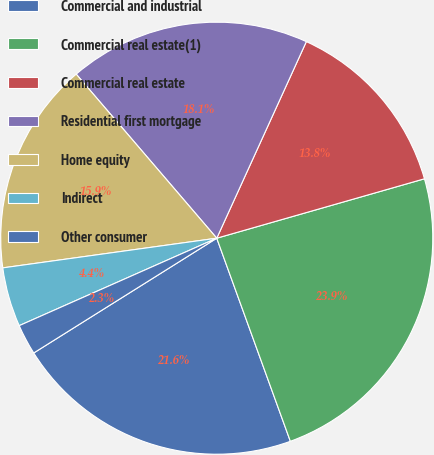Convert chart to OTSL. <chart><loc_0><loc_0><loc_500><loc_500><pie_chart><fcel>Commercial and industrial<fcel>Commercial real estate(1)<fcel>Commercial real estate<fcel>Residential first mortgage<fcel>Home equity<fcel>Indirect<fcel>Other consumer<nl><fcel>21.62%<fcel>23.9%<fcel>13.76%<fcel>18.08%<fcel>15.92%<fcel>4.44%<fcel>2.28%<nl></chart> 